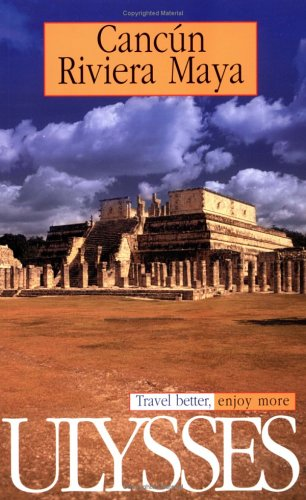What type of book is this? This is a travel guidebook, specifically focused on Cancun and the Riviera Maya, designed to assist travelers in exploring these regions more effectively. 